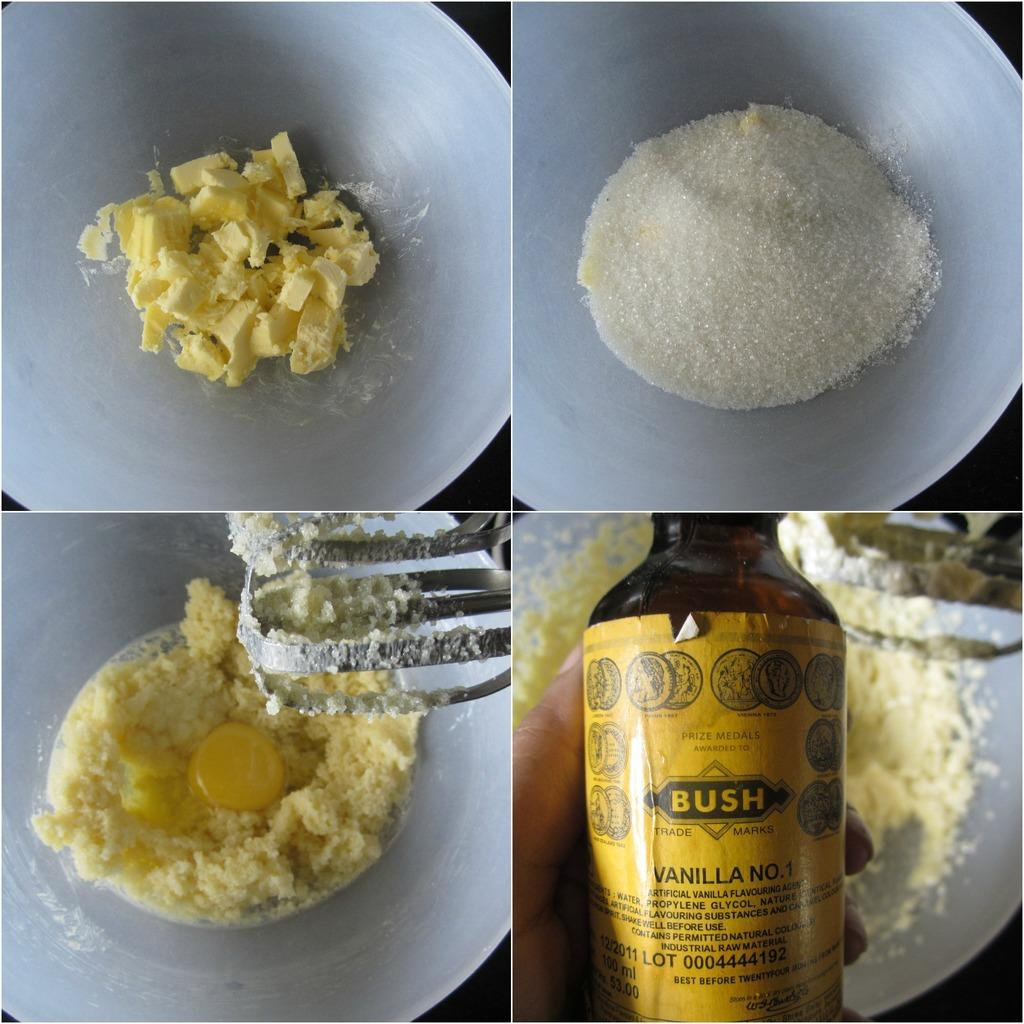<image>
Describe the image concisely. Four plates of various types of food, and a hand holding a yellow bottle of vanilla that says Bush on it. 